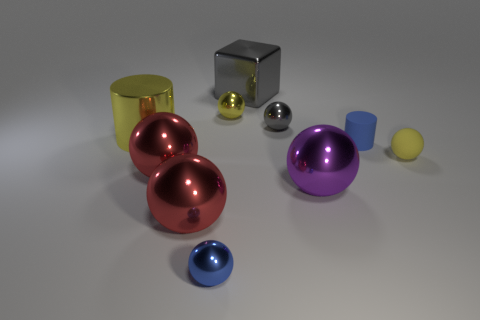How many objects are metal objects that are behind the yellow metallic ball or large metal objects that are on the left side of the purple metallic thing?
Offer a very short reply. 4. How big is the metal ball that is both to the right of the large gray block and behind the purple thing?
Keep it short and to the point. Small. There is a yellow object that is on the right side of the large block; is its shape the same as the small blue rubber thing?
Keep it short and to the point. No. There is a cylinder that is to the right of the yellow thing left of the red thing in front of the large purple shiny thing; what size is it?
Keep it short and to the point. Small. There is a sphere that is the same color as the big cube; what size is it?
Offer a very short reply. Small. What number of things are small matte cylinders or metal balls?
Ensure brevity in your answer.  7. What shape is the yellow thing that is in front of the tiny gray thing and left of the blue rubber cylinder?
Provide a succinct answer. Cylinder. Does the small yellow matte thing have the same shape as the tiny thing that is behind the tiny gray sphere?
Your answer should be very brief. Yes. Are there any tiny blue cylinders behind the blue sphere?
Make the answer very short. Yes. There is a thing that is the same color as the small cylinder; what is it made of?
Your response must be concise. Metal. 